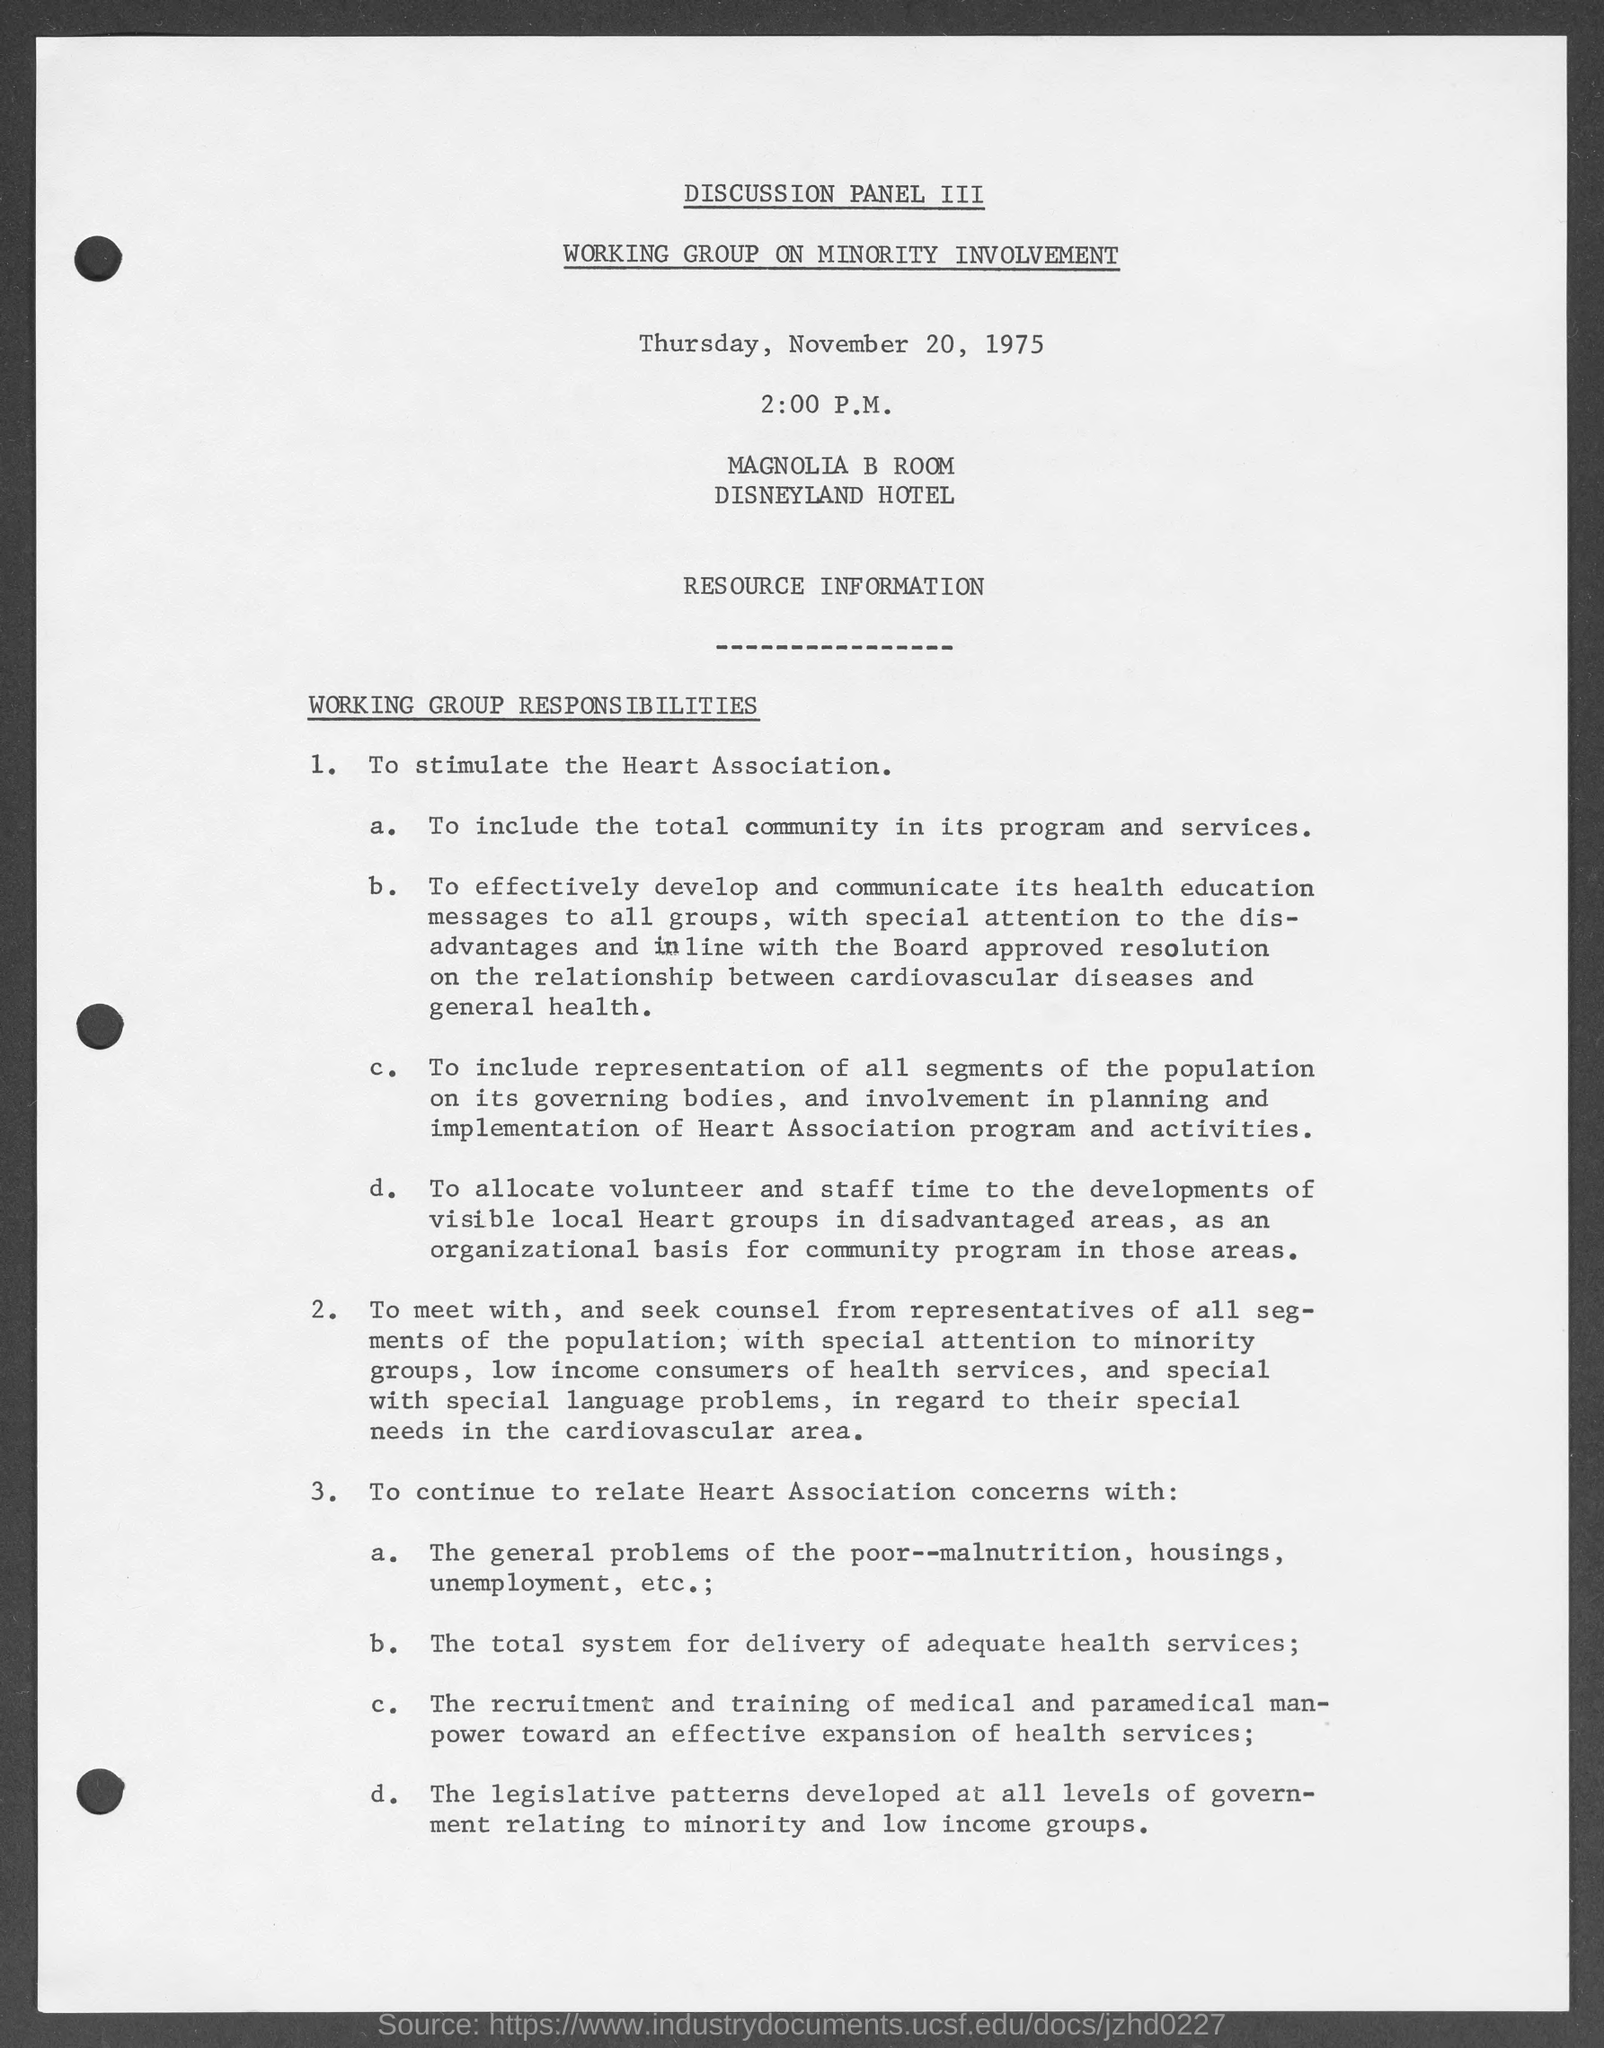Specify some key components in this picture. The Disneyland hotel is named in the given page. The scheduled time mentioned on the given page is 2:00 P.M. 